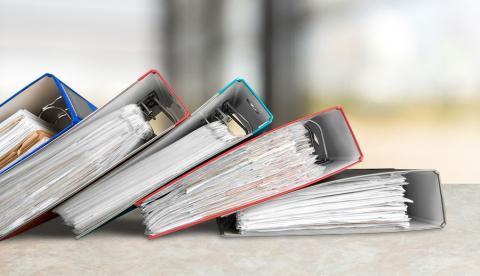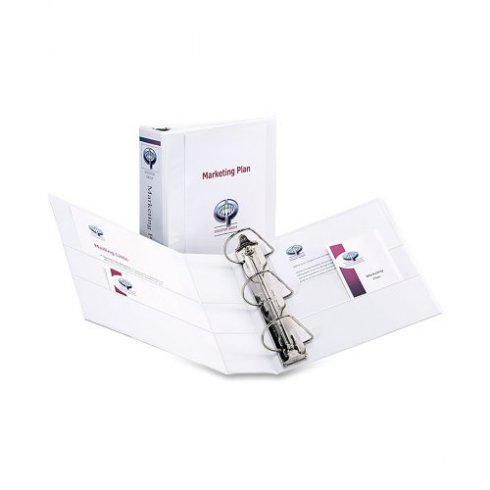The first image is the image on the left, the second image is the image on the right. Assess this claim about the two images: "At least one image shows binders lying on their sides, in a kind of stack.". Correct or not? Answer yes or no. Yes. The first image is the image on the left, the second image is the image on the right. For the images displayed, is the sentence "There is one binder in the the image on the right." factually correct? Answer yes or no. No. 